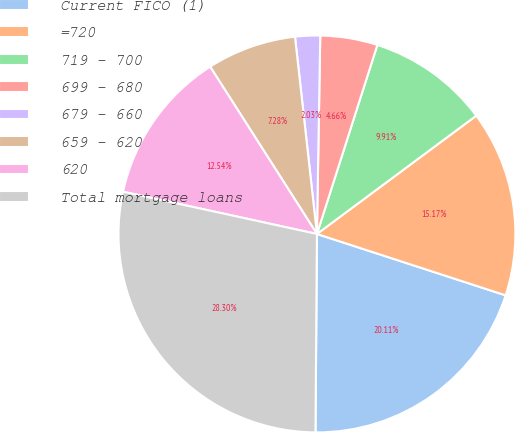Convert chart. <chart><loc_0><loc_0><loc_500><loc_500><pie_chart><fcel>Current FICO (1)<fcel>=720<fcel>719 - 700<fcel>699 - 680<fcel>679 - 660<fcel>659 - 620<fcel>620<fcel>Total mortgage loans<nl><fcel>20.11%<fcel>15.17%<fcel>9.91%<fcel>4.66%<fcel>2.03%<fcel>7.28%<fcel>12.54%<fcel>28.3%<nl></chart> 